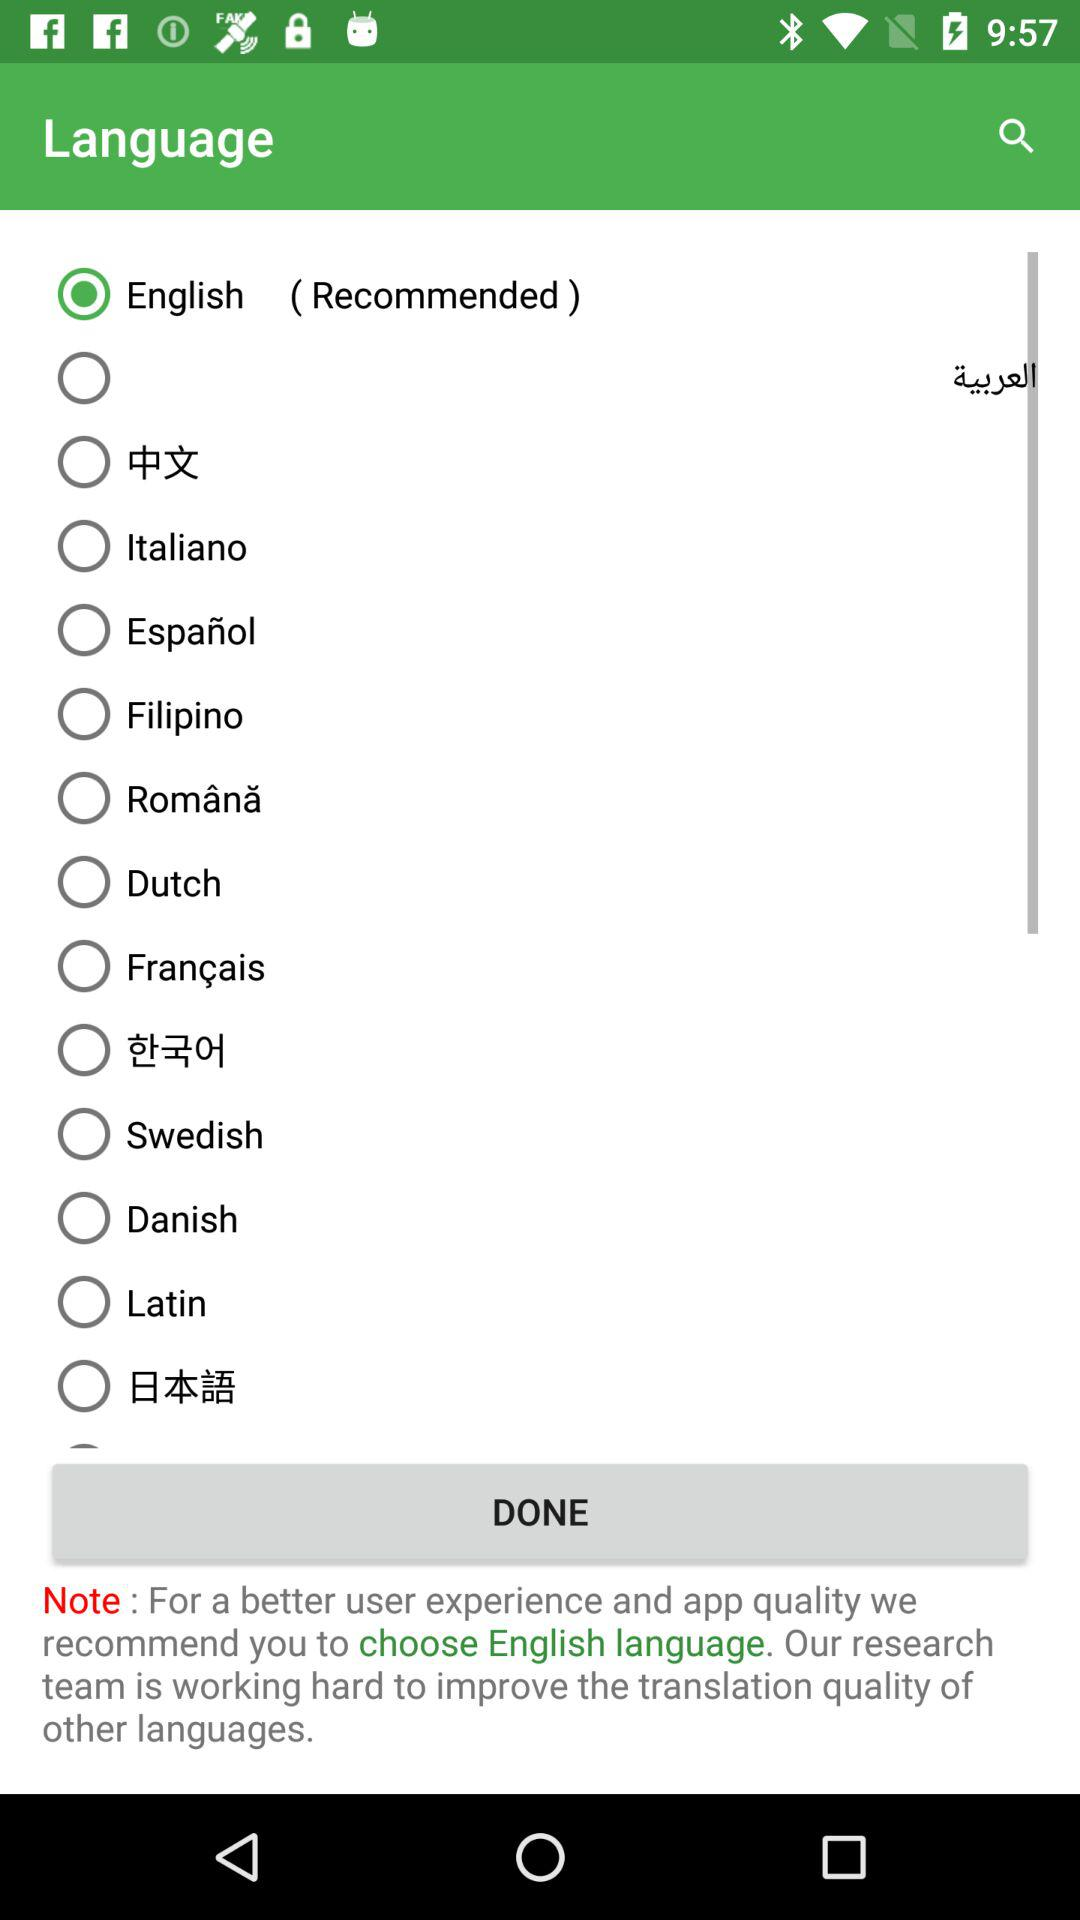Which language option is selected? The selected language is English. 